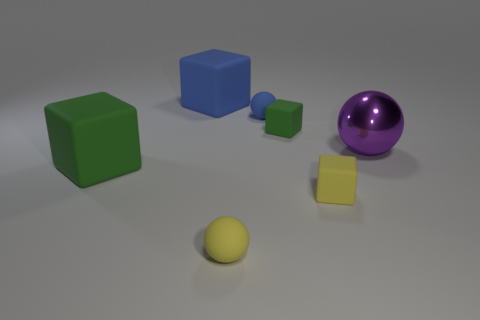Add 3 small yellow matte blocks. How many objects exist? 10 Subtract all blocks. How many objects are left? 3 Subtract all brown matte cylinders. Subtract all purple shiny balls. How many objects are left? 6 Add 1 green rubber cubes. How many green rubber cubes are left? 3 Add 2 gray rubber cylinders. How many gray rubber cylinders exist? 2 Subtract 0 brown cylinders. How many objects are left? 7 